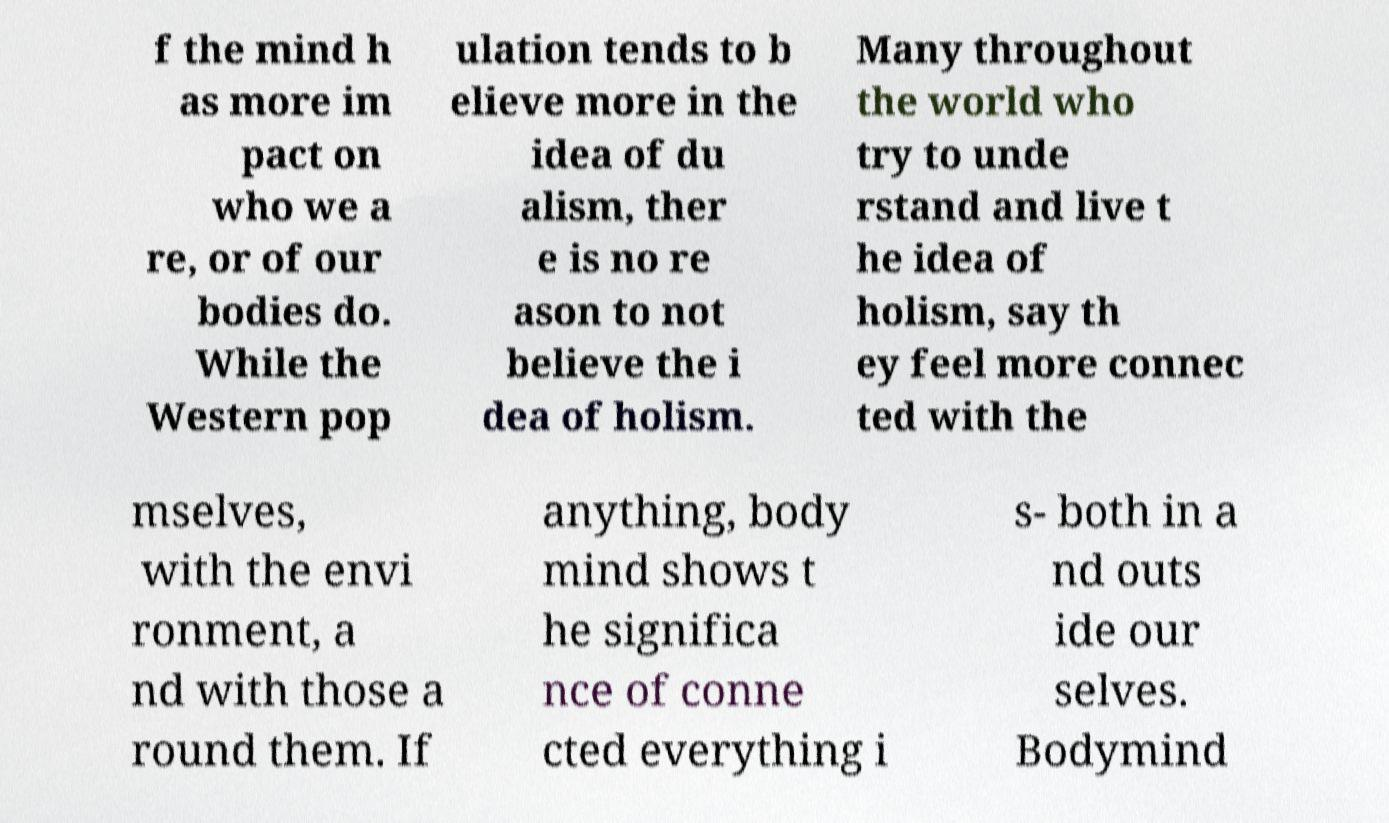For documentation purposes, I need the text within this image transcribed. Could you provide that? f the mind h as more im pact on who we a re, or of our bodies do. While the Western pop ulation tends to b elieve more in the idea of du alism, ther e is no re ason to not believe the i dea of holism. Many throughout the world who try to unde rstand and live t he idea of holism, say th ey feel more connec ted with the mselves, with the envi ronment, a nd with those a round them. If anything, body mind shows t he significa nce of conne cted everything i s- both in a nd outs ide our selves. Bodymind 